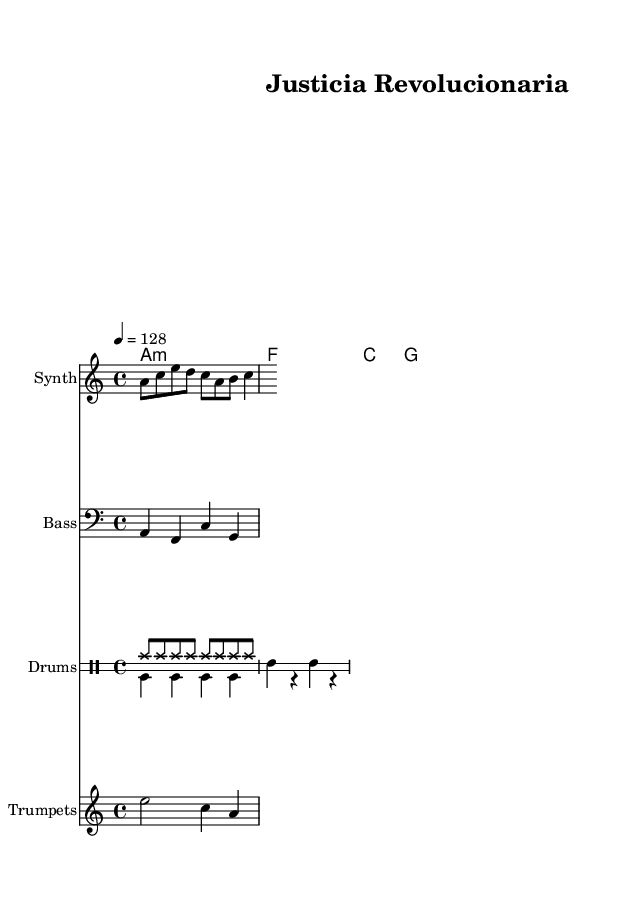What is the key signature of this music? The key signature is A minor, which has one sharp. This is indicated at the beginning of the staff, where it shows the key signature signs.
Answer: A minor What is the time signature of this music? The time signature is 4/4, which means there are four beats in each measure and a quarter note gets one beat. This can be identified at the start of the sheet music right after the key signature.
Answer: 4/4 What is the tempo marking for this piece? The tempo marking indicates the piece should be played at 128 beats per minute, shown at the beginning of the score as "4 = 128." This tells musicians how fast to perform the music.
Answer: 128 What instruments are featured in this score? The score includes synthesizer, bass, drums, and trumpets. Each instrument is labeled at the beginning of each staff, which indicates the parts that will be played.
Answer: Synth, Bass, Drums, Trumpets Which chord appears first in the harmony section? The first chord that appears is A minor, represented as "a1:m" in the harmony section of the score. This shows the root note and chord quality as the starting point for the harmony.
Answer: A minor What type of drum pattern is used in this composition? The composition includes a combination of hi-hat and bass drum patterns; the hi-hat is maintained in a steady rhythm while the bass drum has a more periodic hit pattern. This can be identified in the drum staff notation.
Answer: Hi-hat and bass drum 